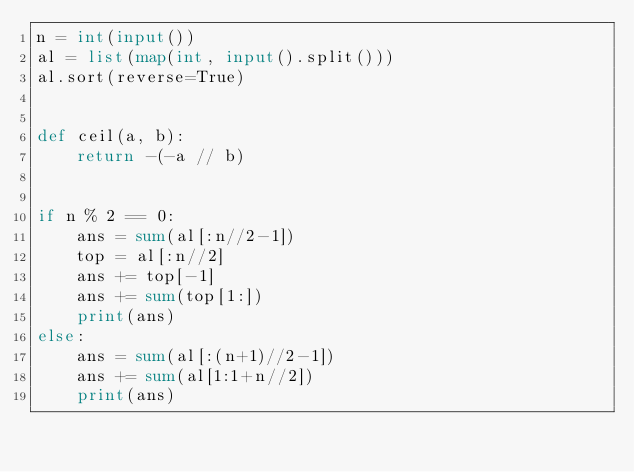Convert code to text. <code><loc_0><loc_0><loc_500><loc_500><_Python_>n = int(input())
al = list(map(int, input().split()))
al.sort(reverse=True)


def ceil(a, b):
    return -(-a // b)


if n % 2 == 0:
    ans = sum(al[:n//2-1])
    top = al[:n//2]
    ans += top[-1]
    ans += sum(top[1:])
    print(ans)
else:
    ans = sum(al[:(n+1)//2-1])
    ans += sum(al[1:1+n//2])
    print(ans)
</code> 